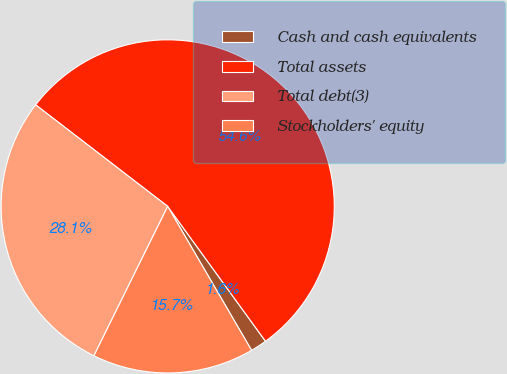Convert chart to OTSL. <chart><loc_0><loc_0><loc_500><loc_500><pie_chart><fcel>Cash and cash equivalents<fcel>Total assets<fcel>Total debt(3)<fcel>Stockholders' equity<nl><fcel>1.59%<fcel>54.58%<fcel>28.13%<fcel>15.7%<nl></chart> 